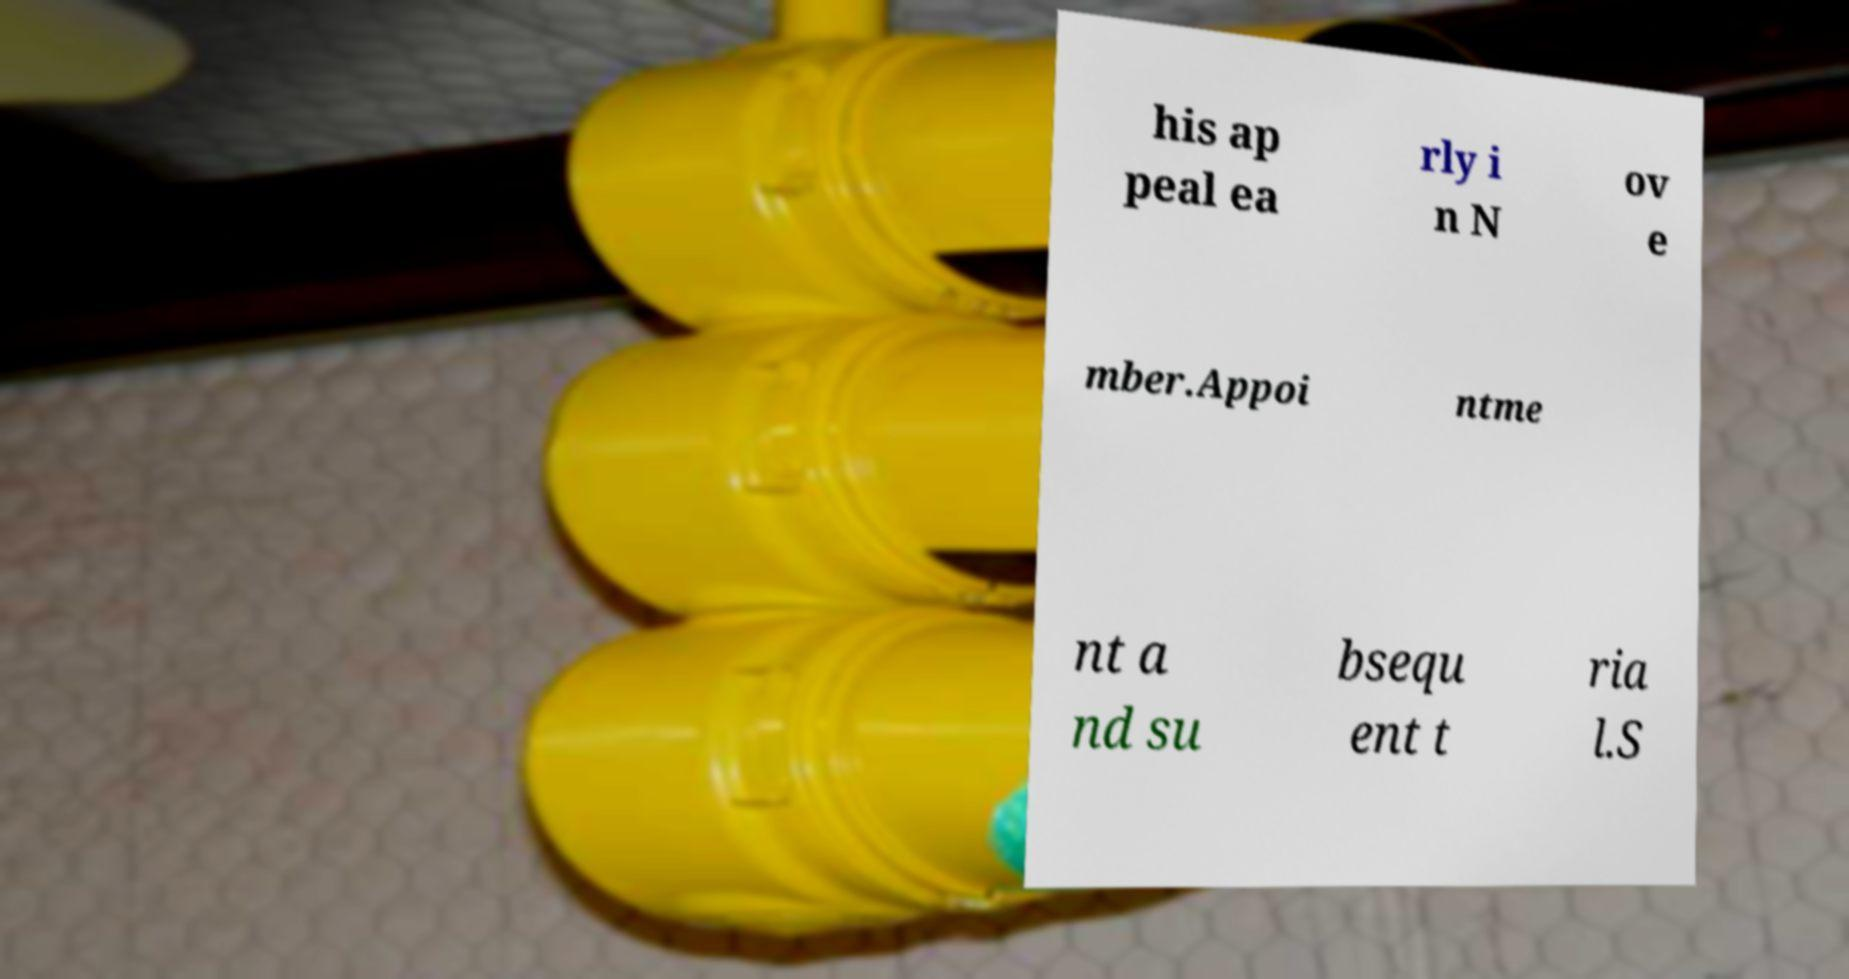Please read and relay the text visible in this image. What does it say? his ap peal ea rly i n N ov e mber.Appoi ntme nt a nd su bsequ ent t ria l.S 